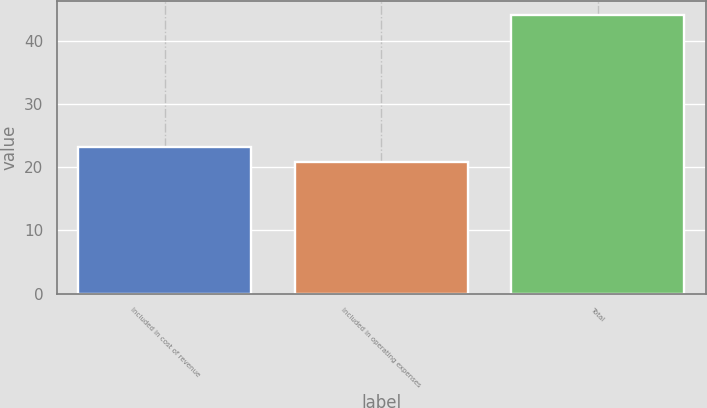Convert chart. <chart><loc_0><loc_0><loc_500><loc_500><bar_chart><fcel>Included in cost of revenue<fcel>Included in operating expenses<fcel>Total<nl><fcel>23.3<fcel>20.8<fcel>44.1<nl></chart> 